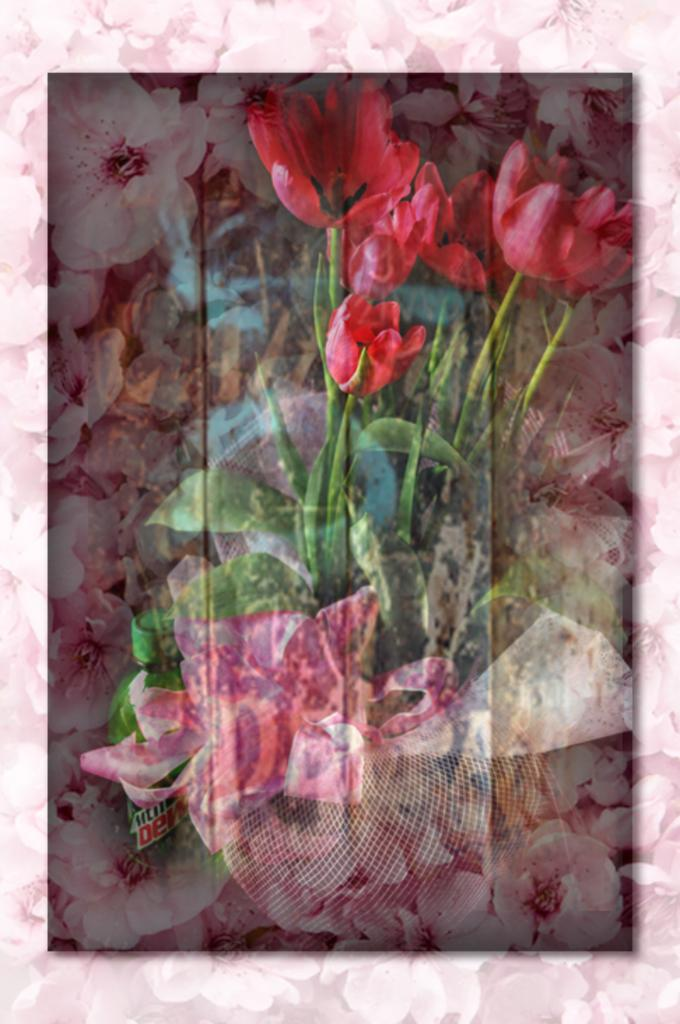What is the main object in the image? There is a greeting card in the image. What design elements are present on the greeting card? The greeting card has flowers and leaves on it. What color is the orange on the greeting card? There is no orange present on the greeting card; it has flowers and leaves as design elements. 